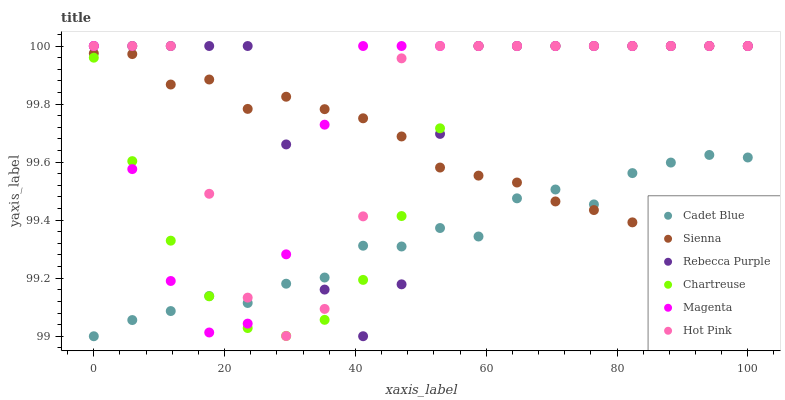Does Cadet Blue have the minimum area under the curve?
Answer yes or no. Yes. Does Rebecca Purple have the maximum area under the curve?
Answer yes or no. Yes. Does Hot Pink have the minimum area under the curve?
Answer yes or no. No. Does Hot Pink have the maximum area under the curve?
Answer yes or no. No. Is Chartreuse the smoothest?
Answer yes or no. Yes. Is Hot Pink the roughest?
Answer yes or no. Yes. Is Sienna the smoothest?
Answer yes or no. No. Is Sienna the roughest?
Answer yes or no. No. Does Cadet Blue have the lowest value?
Answer yes or no. Yes. Does Hot Pink have the lowest value?
Answer yes or no. No. Does Magenta have the highest value?
Answer yes or no. Yes. Does Sienna have the highest value?
Answer yes or no. No. Does Rebecca Purple intersect Sienna?
Answer yes or no. Yes. Is Rebecca Purple less than Sienna?
Answer yes or no. No. Is Rebecca Purple greater than Sienna?
Answer yes or no. No. 